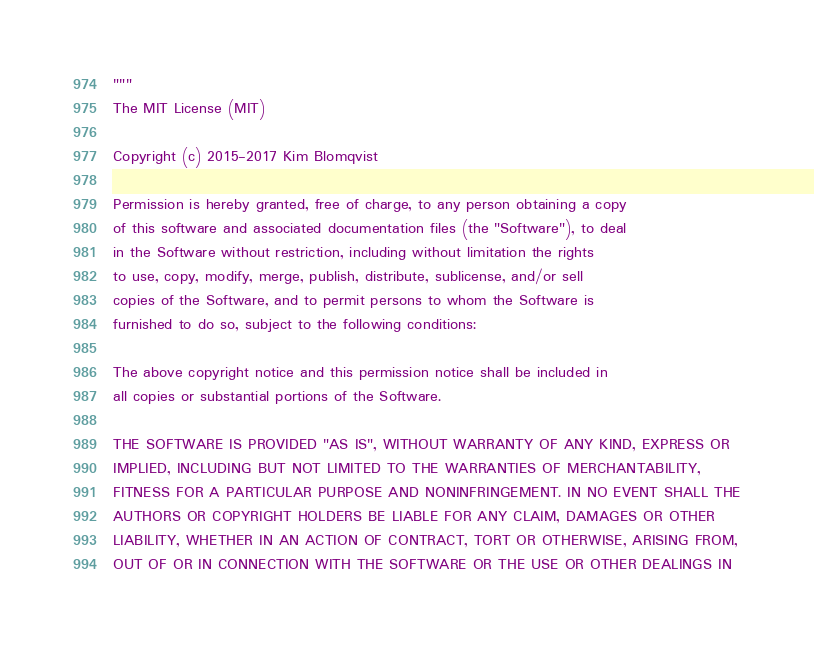<code> <loc_0><loc_0><loc_500><loc_500><_Python_>"""
The MIT License (MIT)

Copyright (c) 2015-2017 Kim Blomqvist

Permission is hereby granted, free of charge, to any person obtaining a copy
of this software and associated documentation files (the "Software"), to deal
in the Software without restriction, including without limitation the rights
to use, copy, modify, merge, publish, distribute, sublicense, and/or sell
copies of the Software, and to permit persons to whom the Software is
furnished to do so, subject to the following conditions:

The above copyright notice and this permission notice shall be included in
all copies or substantial portions of the Software.

THE SOFTWARE IS PROVIDED "AS IS", WITHOUT WARRANTY OF ANY KIND, EXPRESS OR
IMPLIED, INCLUDING BUT NOT LIMITED TO THE WARRANTIES OF MERCHANTABILITY,
FITNESS FOR A PARTICULAR PURPOSE AND NONINFRINGEMENT. IN NO EVENT SHALL THE
AUTHORS OR COPYRIGHT HOLDERS BE LIABLE FOR ANY CLAIM, DAMAGES OR OTHER
LIABILITY, WHETHER IN AN ACTION OF CONTRACT, TORT OR OTHERWISE, ARISING FROM,
OUT OF OR IN CONNECTION WITH THE SOFTWARE OR THE USE OR OTHER DEALINGS IN</code> 